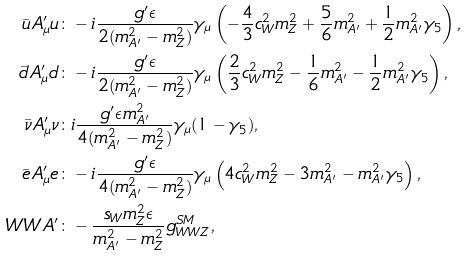Convert formula to latex. <formula><loc_0><loc_0><loc_500><loc_500>\bar { u } A _ { \mu } ^ { \prime } u & \colon - i \frac { g ^ { \prime } \epsilon } { 2 ( m _ { A ^ { \prime } } ^ { 2 } - m _ { Z } ^ { 2 } ) } \gamma _ { \mu } \left ( - \frac { 4 } { 3 } c _ { W } ^ { 2 } m _ { Z } ^ { 2 } + \frac { 5 } { 6 } m _ { A ^ { \prime } } ^ { 2 } + \frac { 1 } { 2 } m _ { A ^ { \prime } } ^ { 2 } \gamma _ { 5 } \right ) , \\ \bar { d } A _ { \mu } ^ { \prime } d & \colon - i \frac { g ^ { \prime } \epsilon } { 2 ( m _ { A ^ { \prime } } ^ { 2 } - m _ { Z } ^ { 2 } ) } \gamma _ { \mu } \left ( \frac { 2 } { 3 } c _ { W } ^ { 2 } m _ { Z } ^ { 2 } - \frac { 1 } { 6 } m _ { A ^ { \prime } } ^ { 2 } - \frac { 1 } { 2 } m _ { A ^ { \prime } } ^ { 2 } \gamma _ { 5 } \right ) , \\ \bar { \nu } A _ { \mu } ^ { \prime } \nu & \colon i \frac { g ^ { \prime } \epsilon m _ { A ^ { \prime } } ^ { 2 } } { 4 ( m _ { A ^ { \prime } } ^ { 2 } - m _ { Z } ^ { 2 } ) } \gamma _ { \mu } ( 1 - \gamma _ { 5 } ) , \\ \bar { e } A _ { \mu } ^ { \prime } e & \colon - i \frac { g ^ { \prime } \epsilon } { 4 ( m _ { A ^ { \prime } } ^ { 2 } - m _ { Z } ^ { 2 } ) } \gamma _ { \mu } \left ( 4 c _ { W } ^ { 2 } m _ { Z } ^ { 2 } - 3 m _ { A ^ { \prime } } ^ { 2 } - m _ { A ^ { \prime } } ^ { 2 } \gamma _ { 5 } \right ) , \\ W W A ^ { \prime } & \colon - \frac { s _ { W } m _ { Z } ^ { 2 } \epsilon } { m _ { A ^ { \prime } } ^ { 2 } - m _ { Z } ^ { 2 } } g _ { W W Z } ^ { S M } ,</formula> 